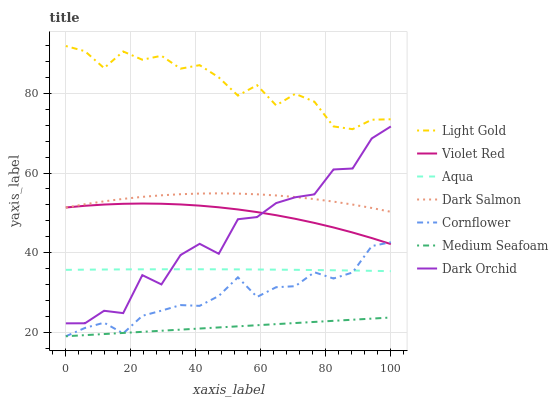Does Violet Red have the minimum area under the curve?
Answer yes or no. No. Does Violet Red have the maximum area under the curve?
Answer yes or no. No. Is Violet Red the smoothest?
Answer yes or no. No. Is Violet Red the roughest?
Answer yes or no. No. Does Violet Red have the lowest value?
Answer yes or no. No. Does Violet Red have the highest value?
Answer yes or no. No. Is Cornflower less than Light Gold?
Answer yes or no. Yes. Is Light Gold greater than Cornflower?
Answer yes or no. Yes. Does Cornflower intersect Light Gold?
Answer yes or no. No. 